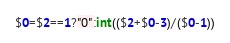<code> <loc_0><loc_0><loc_500><loc_500><_Awk_>$0=$2==1?"0":int(($2+$0-3)/($0-1))</code> 